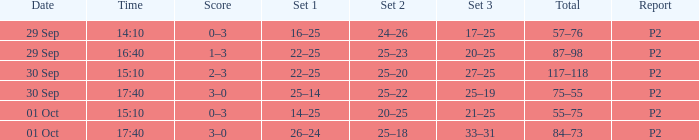For a date of 29 sep and a time of 16:40, what is the associated set 3? 20–25. 